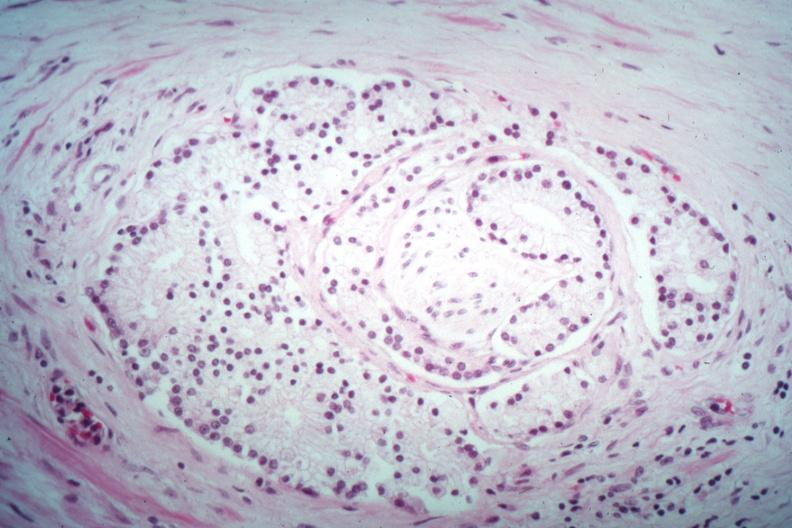what does this image show?
Answer the question using a single word or phrase. Nice perineural invasion by well differentiated adenocarcinoma 